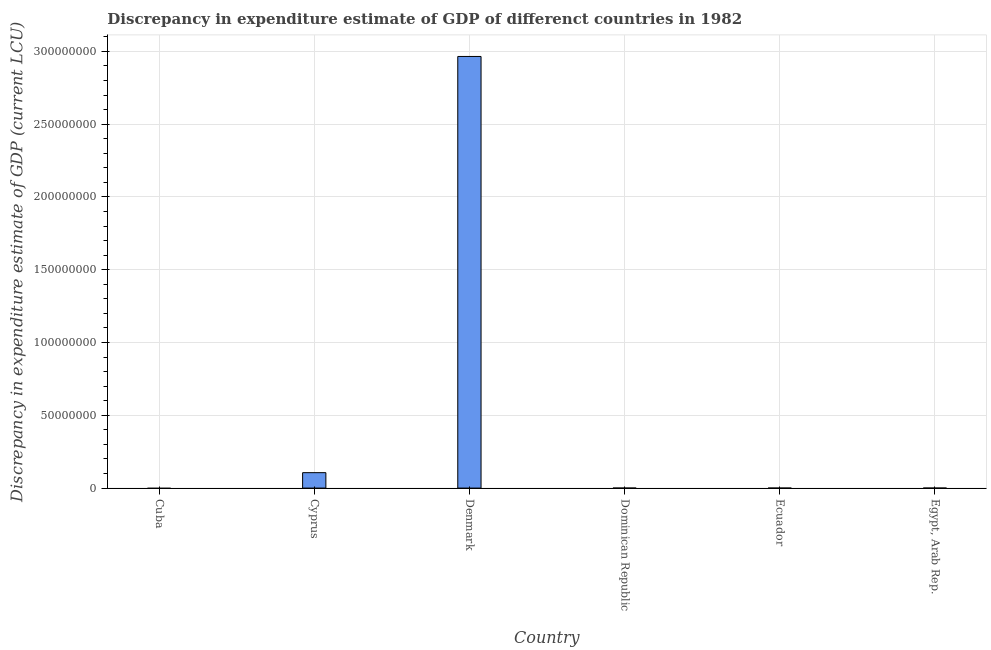Does the graph contain any zero values?
Your response must be concise. Yes. What is the title of the graph?
Provide a short and direct response. Discrepancy in expenditure estimate of GDP of differenct countries in 1982. What is the label or title of the X-axis?
Your answer should be compact. Country. What is the label or title of the Y-axis?
Offer a very short reply. Discrepancy in expenditure estimate of GDP (current LCU). What is the discrepancy in expenditure estimate of gdp in Denmark?
Provide a short and direct response. 2.96e+08. Across all countries, what is the maximum discrepancy in expenditure estimate of gdp?
Ensure brevity in your answer.  2.96e+08. Across all countries, what is the minimum discrepancy in expenditure estimate of gdp?
Provide a short and direct response. 0. In which country was the discrepancy in expenditure estimate of gdp maximum?
Your response must be concise. Denmark. What is the sum of the discrepancy in expenditure estimate of gdp?
Make the answer very short. 3.07e+08. What is the difference between the discrepancy in expenditure estimate of gdp in Cyprus and Egypt, Arab Rep.?
Provide a succinct answer. 1.06e+07. What is the average discrepancy in expenditure estimate of gdp per country?
Your response must be concise. 5.12e+07. What is the median discrepancy in expenditure estimate of gdp?
Your answer should be compact. 600. What is the ratio of the discrepancy in expenditure estimate of gdp in Denmark to that in Dominican Republic?
Offer a very short reply. 1.48e+06. Is the difference between the discrepancy in expenditure estimate of gdp in Cyprus and Dominican Republic greater than the difference between any two countries?
Provide a short and direct response. No. What is the difference between the highest and the second highest discrepancy in expenditure estimate of gdp?
Your response must be concise. 2.86e+08. Is the sum of the discrepancy in expenditure estimate of gdp in Cyprus and Egypt, Arab Rep. greater than the maximum discrepancy in expenditure estimate of gdp across all countries?
Provide a short and direct response. No. What is the difference between the highest and the lowest discrepancy in expenditure estimate of gdp?
Offer a very short reply. 2.96e+08. Are the values on the major ticks of Y-axis written in scientific E-notation?
Your response must be concise. No. What is the Discrepancy in expenditure estimate of GDP (current LCU) in Cuba?
Keep it short and to the point. 0. What is the Discrepancy in expenditure estimate of GDP (current LCU) of Cyprus?
Offer a terse response. 1.06e+07. What is the Discrepancy in expenditure estimate of GDP (current LCU) in Denmark?
Your response must be concise. 2.96e+08. What is the Discrepancy in expenditure estimate of GDP (current LCU) of Dominican Republic?
Provide a short and direct response. 200. What is the Discrepancy in expenditure estimate of GDP (current LCU) of Ecuador?
Provide a short and direct response. 0. What is the Discrepancy in expenditure estimate of GDP (current LCU) of Egypt, Arab Rep.?
Your answer should be compact. 1000. What is the difference between the Discrepancy in expenditure estimate of GDP (current LCU) in Cyprus and Denmark?
Offer a very short reply. -2.86e+08. What is the difference between the Discrepancy in expenditure estimate of GDP (current LCU) in Cyprus and Dominican Republic?
Provide a succinct answer. 1.06e+07. What is the difference between the Discrepancy in expenditure estimate of GDP (current LCU) in Cyprus and Egypt, Arab Rep.?
Provide a succinct answer. 1.06e+07. What is the difference between the Discrepancy in expenditure estimate of GDP (current LCU) in Denmark and Dominican Republic?
Ensure brevity in your answer.  2.96e+08. What is the difference between the Discrepancy in expenditure estimate of GDP (current LCU) in Denmark and Egypt, Arab Rep.?
Keep it short and to the point. 2.96e+08. What is the difference between the Discrepancy in expenditure estimate of GDP (current LCU) in Dominican Republic and Egypt, Arab Rep.?
Your answer should be very brief. -800. What is the ratio of the Discrepancy in expenditure estimate of GDP (current LCU) in Cyprus to that in Denmark?
Provide a succinct answer. 0.04. What is the ratio of the Discrepancy in expenditure estimate of GDP (current LCU) in Cyprus to that in Dominican Republic?
Your response must be concise. 5.30e+04. What is the ratio of the Discrepancy in expenditure estimate of GDP (current LCU) in Cyprus to that in Egypt, Arab Rep.?
Your answer should be very brief. 1.06e+04. What is the ratio of the Discrepancy in expenditure estimate of GDP (current LCU) in Denmark to that in Dominican Republic?
Your answer should be compact. 1.48e+06. What is the ratio of the Discrepancy in expenditure estimate of GDP (current LCU) in Denmark to that in Egypt, Arab Rep.?
Ensure brevity in your answer.  2.96e+05. What is the ratio of the Discrepancy in expenditure estimate of GDP (current LCU) in Dominican Republic to that in Egypt, Arab Rep.?
Give a very brief answer. 0.2. 